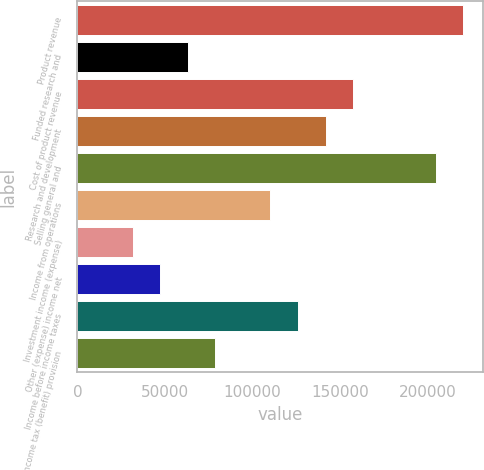<chart> <loc_0><loc_0><loc_500><loc_500><bar_chart><fcel>Product revenue<fcel>Funded research and<fcel>Cost of product revenue<fcel>Research and development<fcel>Selling general and<fcel>Income from operations<fcel>Investment income (expense)<fcel>Other (expense) income net<fcel>Income before income taxes<fcel>Income tax (benefit) provision<nl><fcel>220659<fcel>63045.8<fcel>157614<fcel>141853<fcel>204898<fcel>110330<fcel>31523.1<fcel>47284.4<fcel>126091<fcel>78807.2<nl></chart> 